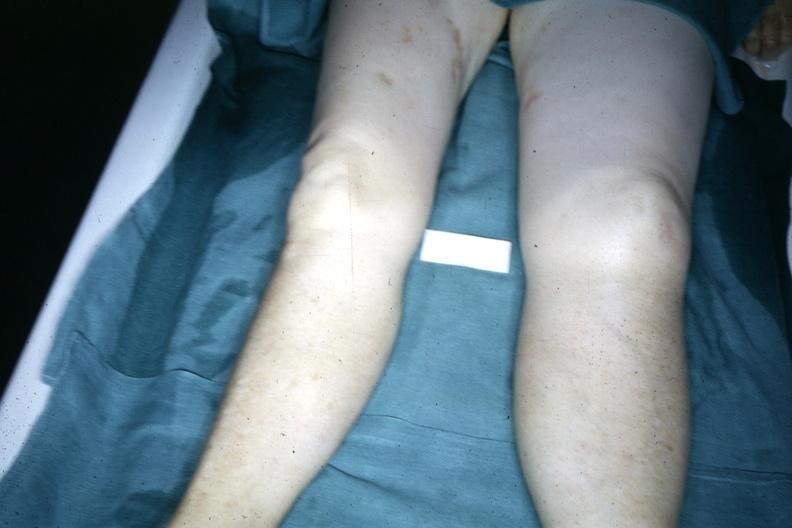what demonstrated with one about twice the size of the other due to malignant lymphoma involving lymphatic drainage?
Answer the question using a single word or phrase. Legs 